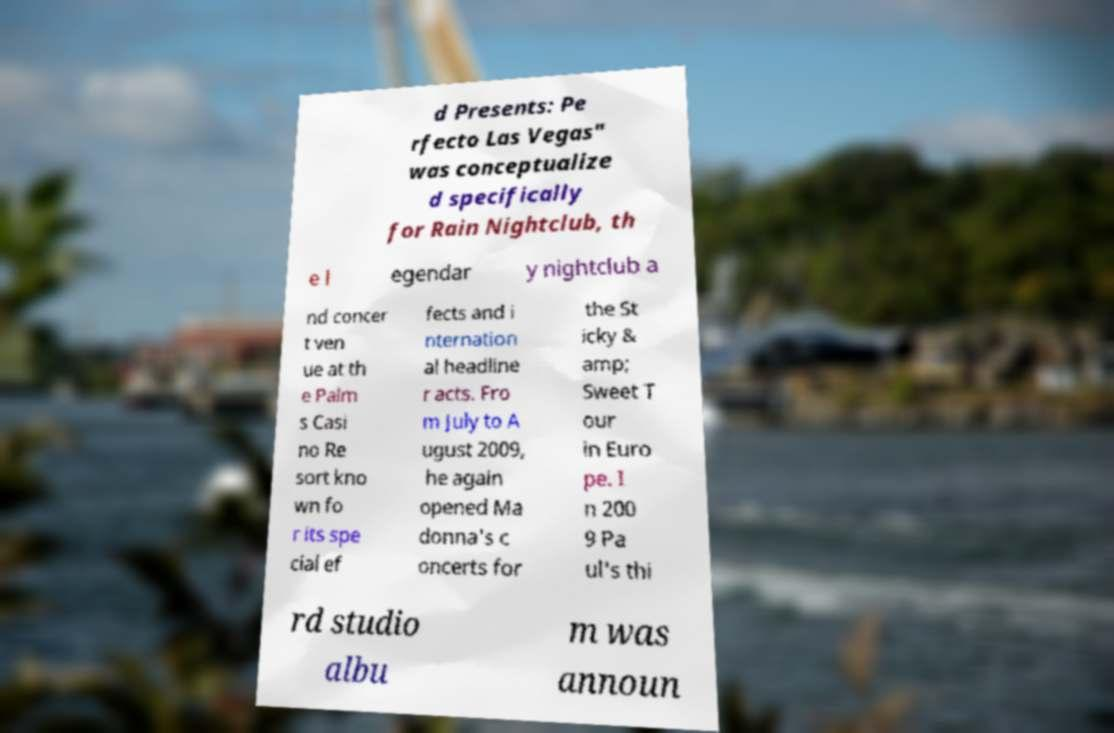Could you extract and type out the text from this image? d Presents: Pe rfecto Las Vegas" was conceptualize d specifically for Rain Nightclub, th e l egendar y nightclub a nd concer t ven ue at th e Palm s Casi no Re sort kno wn fo r its spe cial ef fects and i nternation al headline r acts. Fro m July to A ugust 2009, he again opened Ma donna's c oncerts for the St icky & amp; Sweet T our in Euro pe. I n 200 9 Pa ul's thi rd studio albu m was announ 